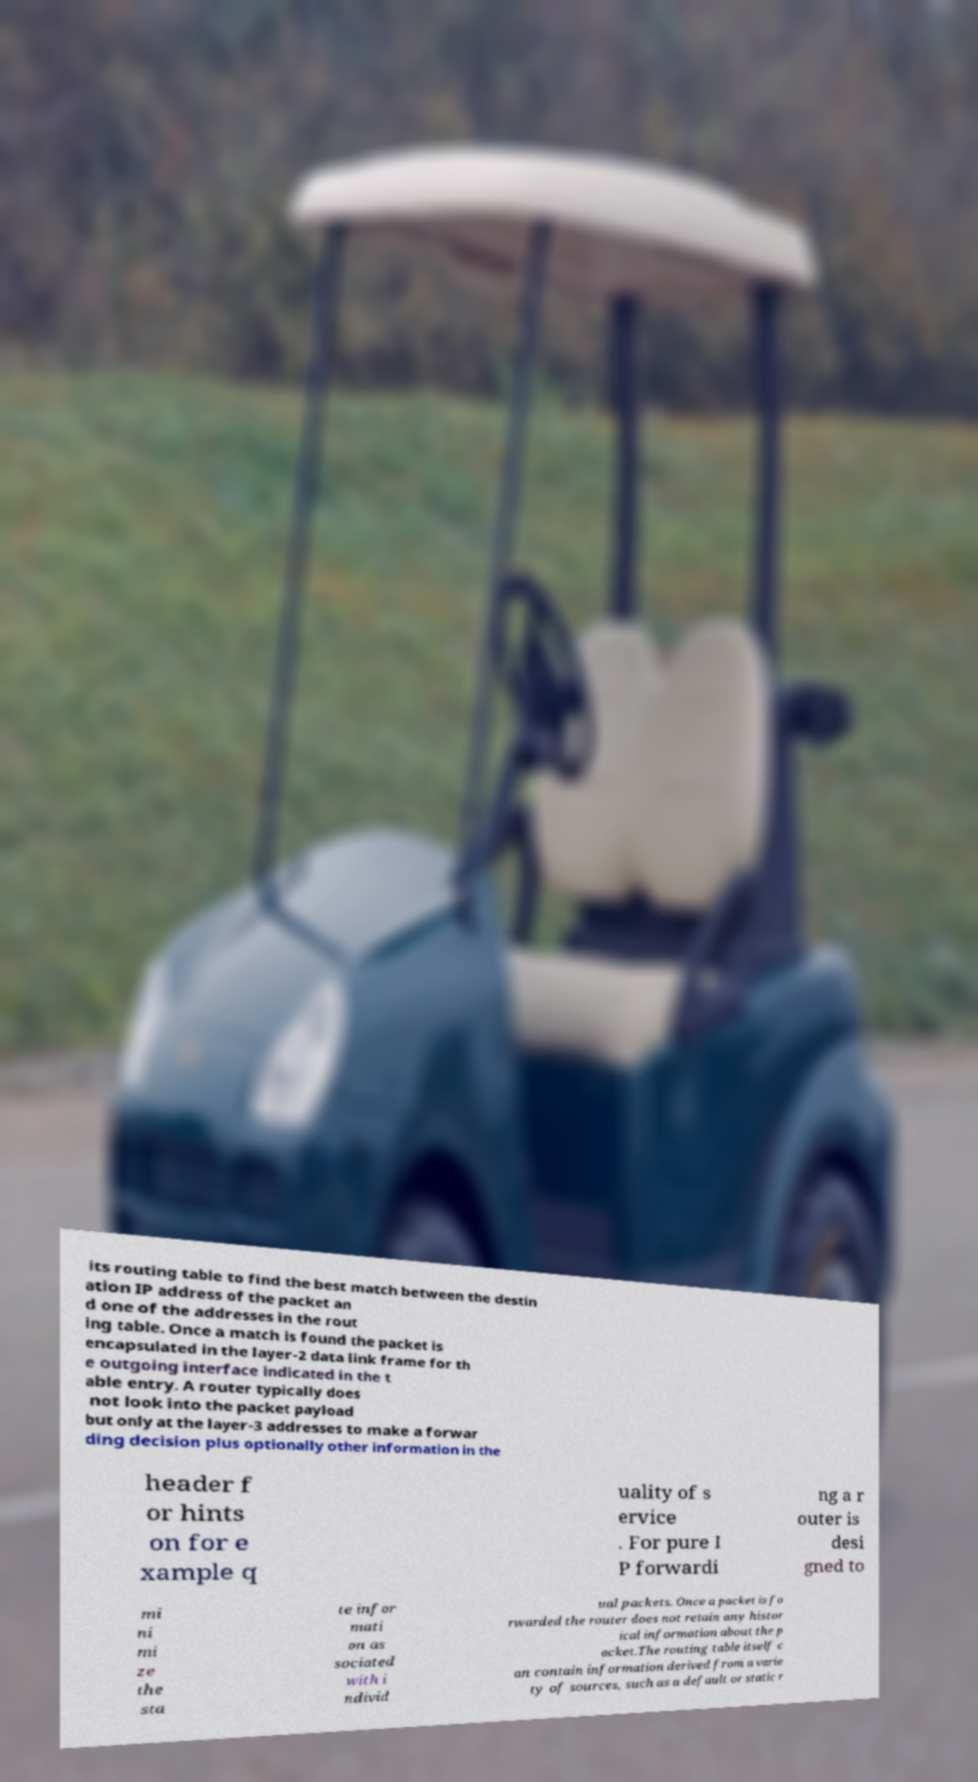Could you assist in decoding the text presented in this image and type it out clearly? its routing table to find the best match between the destin ation IP address of the packet an d one of the addresses in the rout ing table. Once a match is found the packet is encapsulated in the layer-2 data link frame for th e outgoing interface indicated in the t able entry. A router typically does not look into the packet payload but only at the layer-3 addresses to make a forwar ding decision plus optionally other information in the header f or hints on for e xample q uality of s ervice . For pure I P forwardi ng a r outer is desi gned to mi ni mi ze the sta te infor mati on as sociated with i ndivid ual packets. Once a packet is fo rwarded the router does not retain any histor ical information about the p acket.The routing table itself c an contain information derived from a varie ty of sources, such as a default or static r 